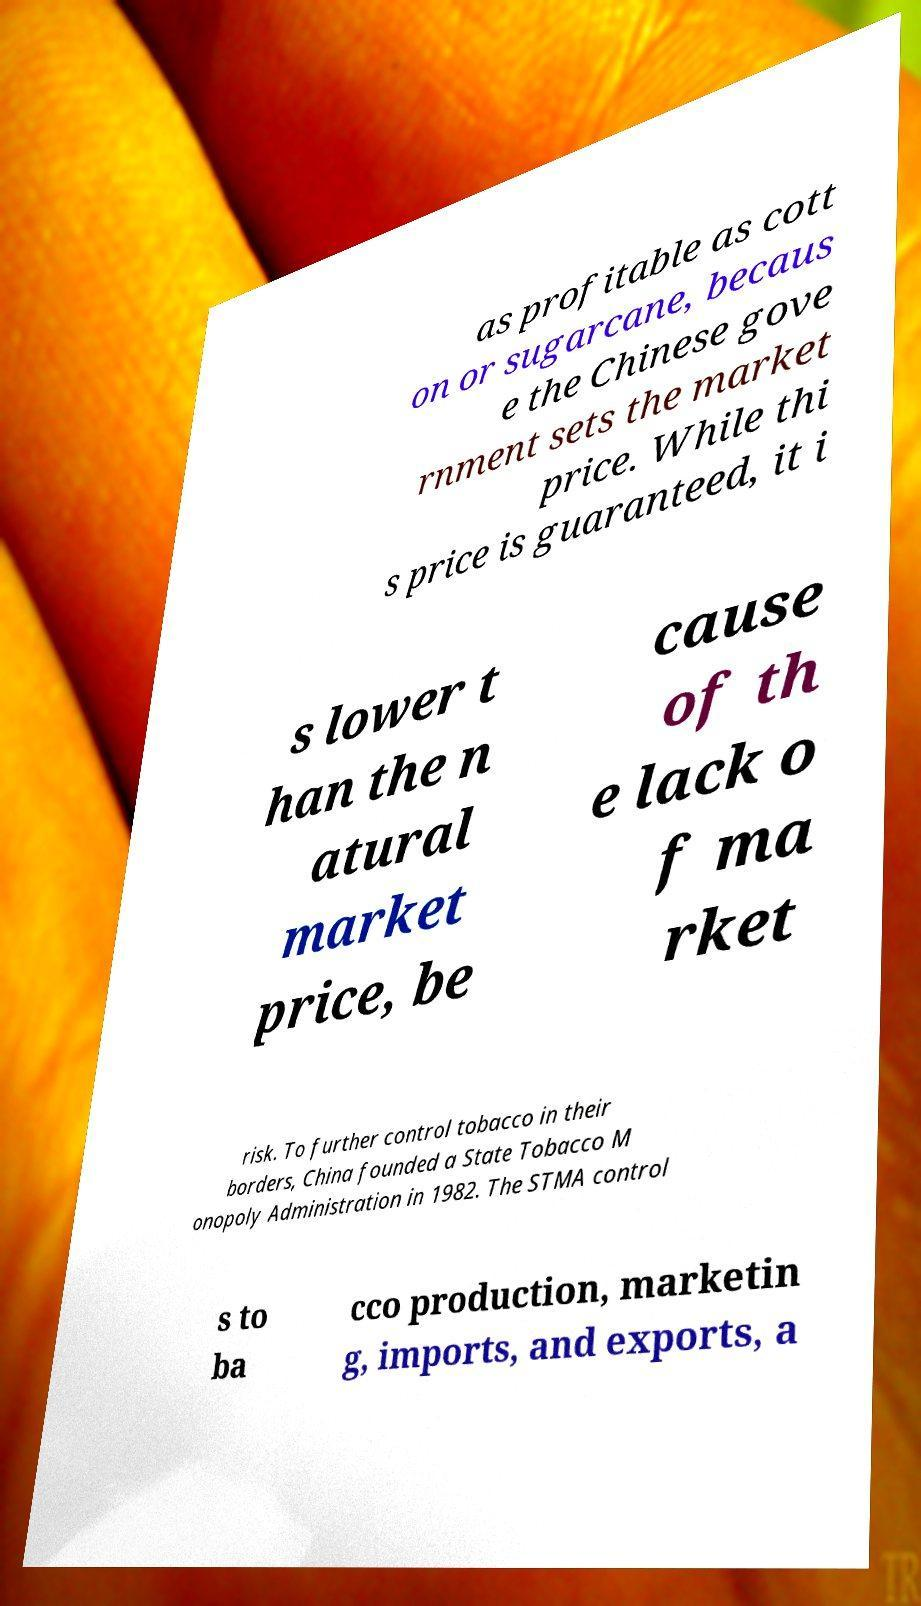Please identify and transcribe the text found in this image. as profitable as cott on or sugarcane, becaus e the Chinese gove rnment sets the market price. While thi s price is guaranteed, it i s lower t han the n atural market price, be cause of th e lack o f ma rket risk. To further control tobacco in their borders, China founded a State Tobacco M onopoly Administration in 1982. The STMA control s to ba cco production, marketin g, imports, and exports, a 